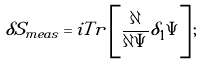<formula> <loc_0><loc_0><loc_500><loc_500>\delta S _ { m e a s } = i T r \left [ \frac { \partial } { \partial \Psi } \tilde { \delta } _ { 1 } \Psi \right ] ;</formula> 